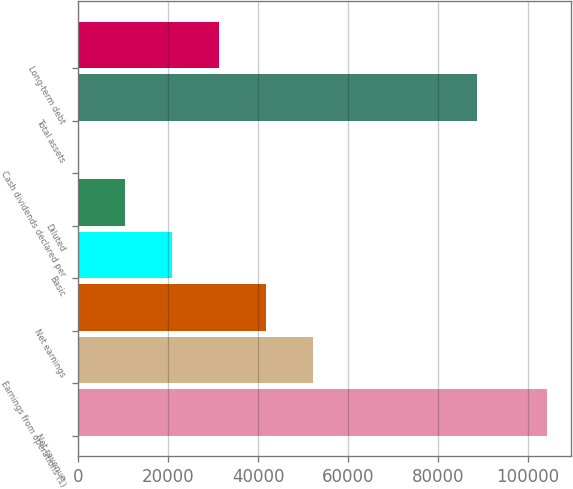<chart> <loc_0><loc_0><loc_500><loc_500><bar_chart><fcel>Net revenue<fcel>Earnings from operations (1)<fcel>Net earnings<fcel>Basic<fcel>Diluted<fcel>Cash dividends declared per<fcel>Total assets<fcel>Long-term debt<nl><fcel>104286<fcel>52143.2<fcel>41714.6<fcel>20857.5<fcel>10428.9<fcel>0.32<fcel>88699<fcel>31286<nl></chart> 